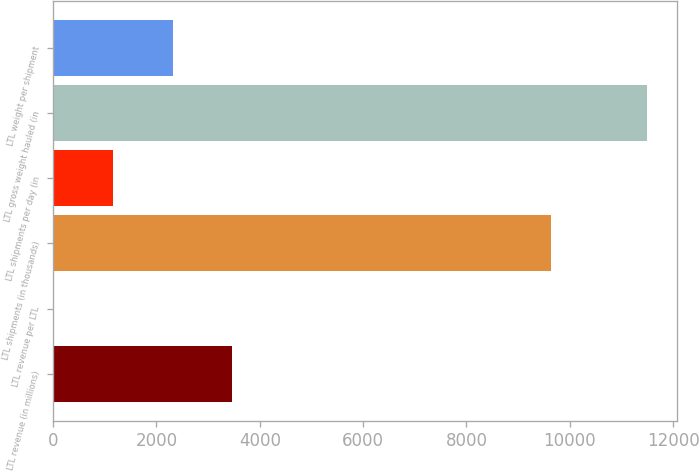Convert chart to OTSL. <chart><loc_0><loc_0><loc_500><loc_500><bar_chart><fcel>LTL revenue (in millions)<fcel>LTL revenue per LTL<fcel>LTL shipments (in thousands)<fcel>LTL shipments per day (in<fcel>LTL gross weight hauled (in<fcel>LTL weight per shipment<nl><fcel>3460.56<fcel>15.93<fcel>9638<fcel>1164.14<fcel>11498<fcel>2312.35<nl></chart> 